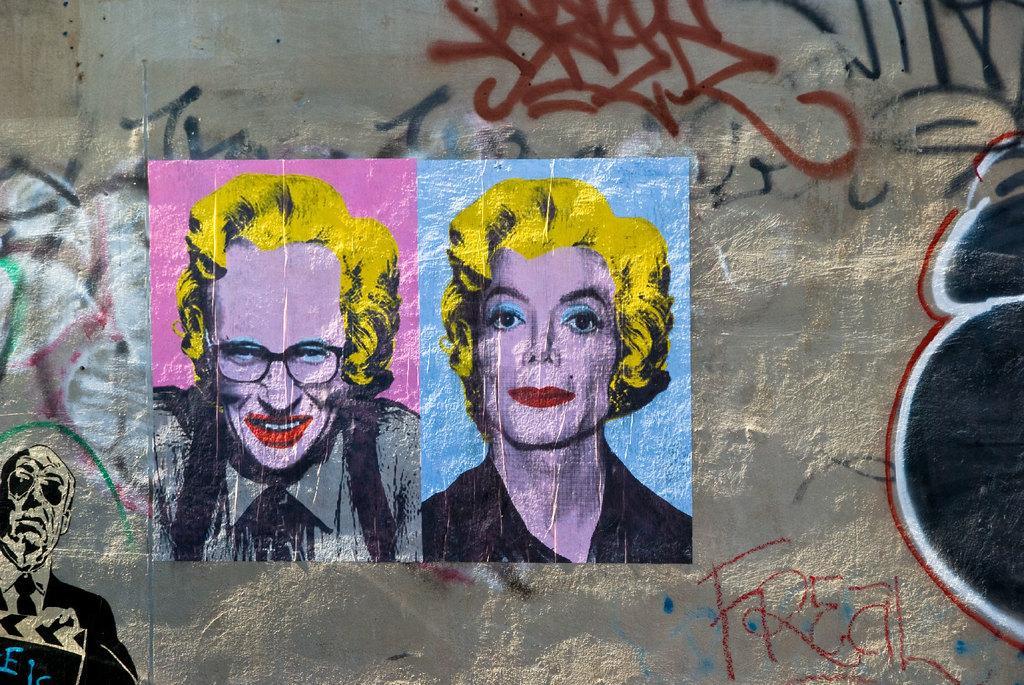Please provide a concise description of this image. In the center of the image there is a painting on the wall. 